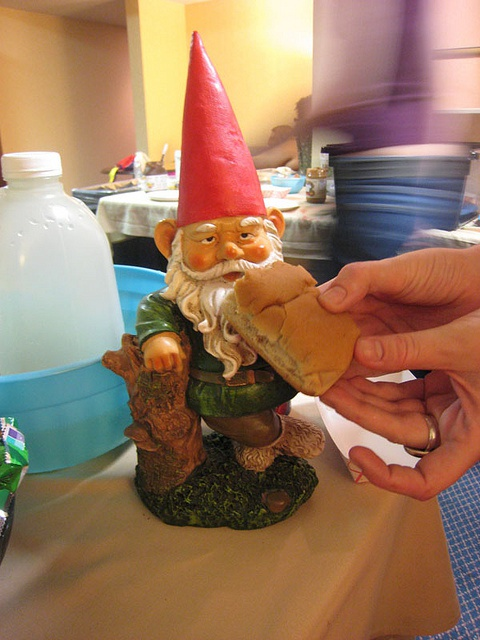Describe the objects in this image and their specific colors. I can see bottle in tan, lightgray, teal, darkgray, and lightblue tones, people in tan, brown, and maroon tones, bowl in tan, teal, and lightblue tones, sandwich in tan, brown, and maroon tones, and dining table in tan, white, darkgray, and gray tones in this image. 